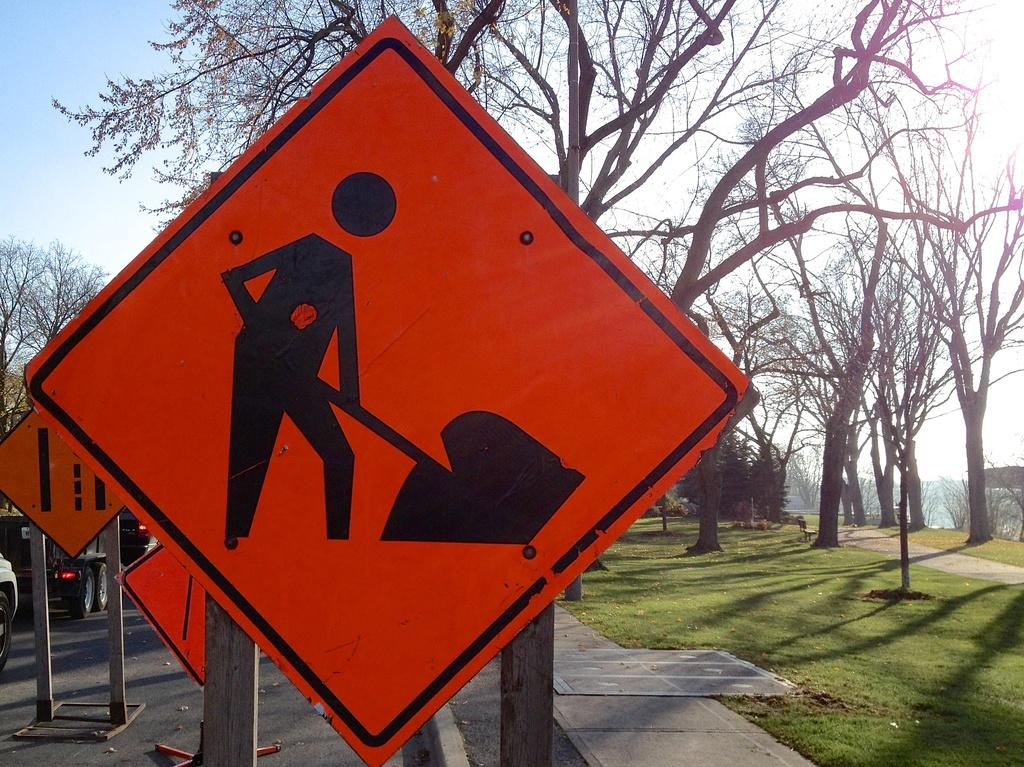What can be seen on the sign boards in the image? The information on the sign boards is not visible in the image. What types of vehicles are on the road in the image? The types of vehicles on the road are not specified in the image. What is located behind the vehicles in the image? There are trees and the sky visible in the background of the image. Are there any bears eating berries near the sign boards in the image? No, there are no bears or berries present in the image. 